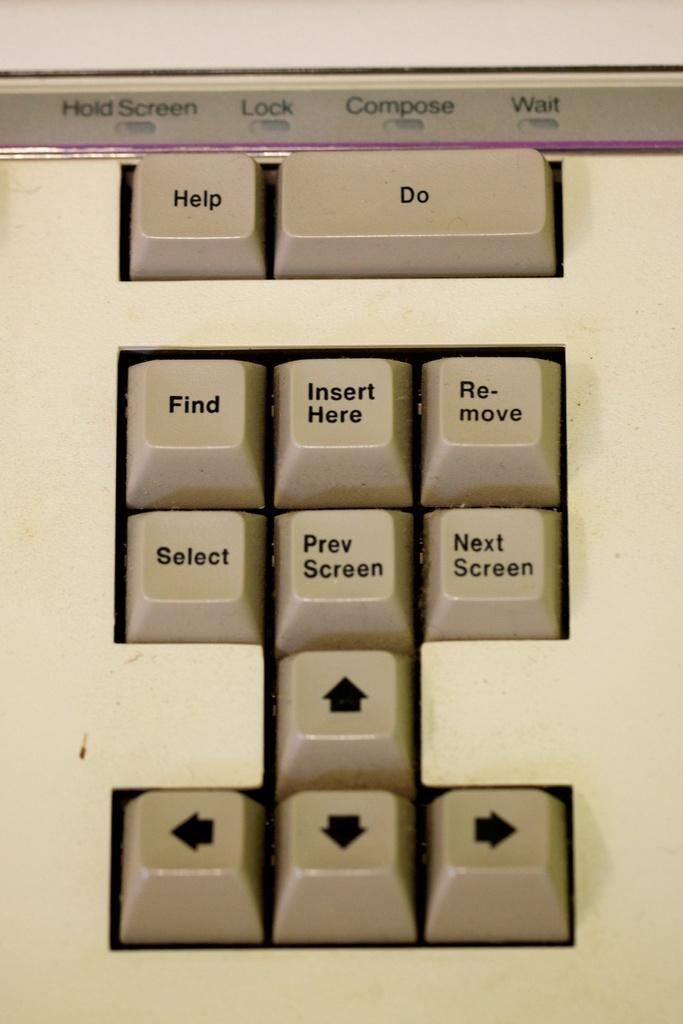<image>
Write a terse but informative summary of the picture. A keyboard with many keys including find, select and help. 